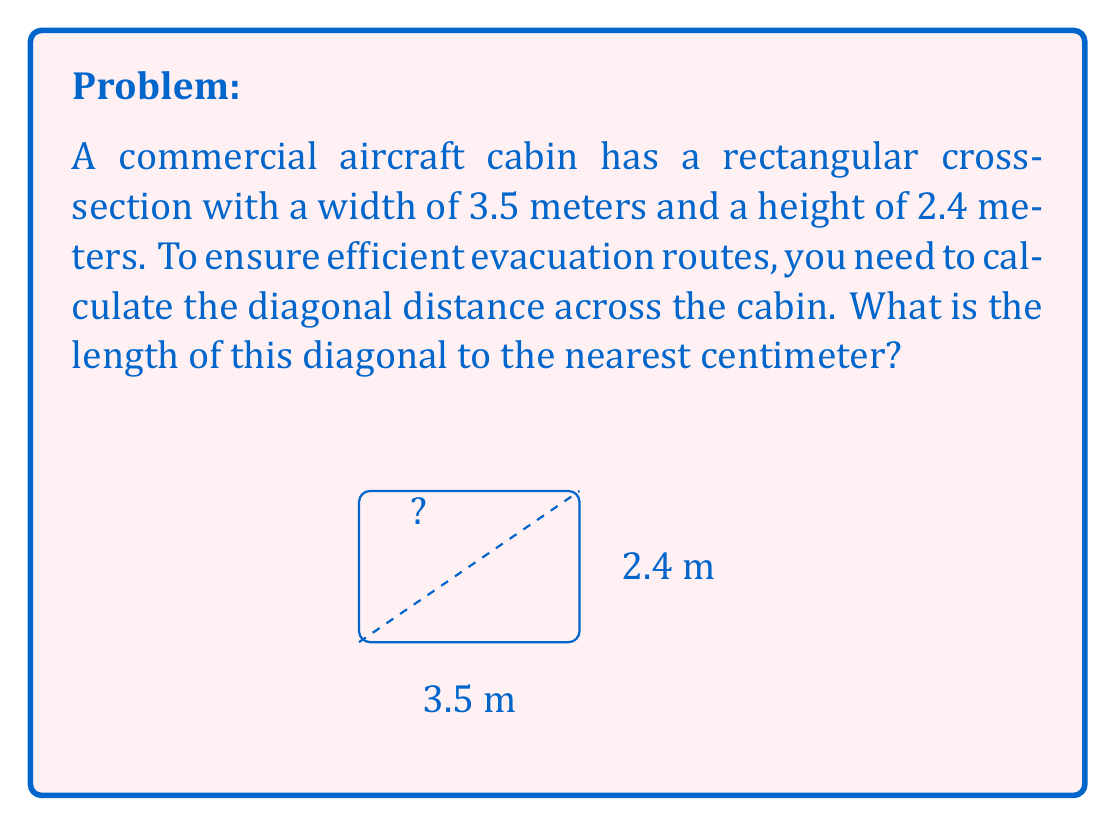Help me with this question. To solve this problem, we can use the Pythagorean theorem, as the diagonal forms the hypotenuse of a right triangle with the width and height as the other two sides.

1) Let's denote the diagonal as $d$. According to the Pythagorean theorem:

   $$d^2 = 3.5^2 + 2.4^2$$

2) Simplify the right side:
   $$d^2 = 12.25 + 5.76 = 18.01$$

3) Take the square root of both sides:
   $$d = \sqrt{18.01}$$

4) Calculate this value:
   $$d \approx 4.2437 \text{ meters}$$

5) Rounding to the nearest centimeter:
   $$d \approx 4.24 \text{ meters}$$

This diagonal measurement is crucial for flight attendants to understand the maximum distance they might need to traverse during an emergency evacuation, ensuring they can efficiently guide passengers to the nearest exits.
Answer: 4.24 m 